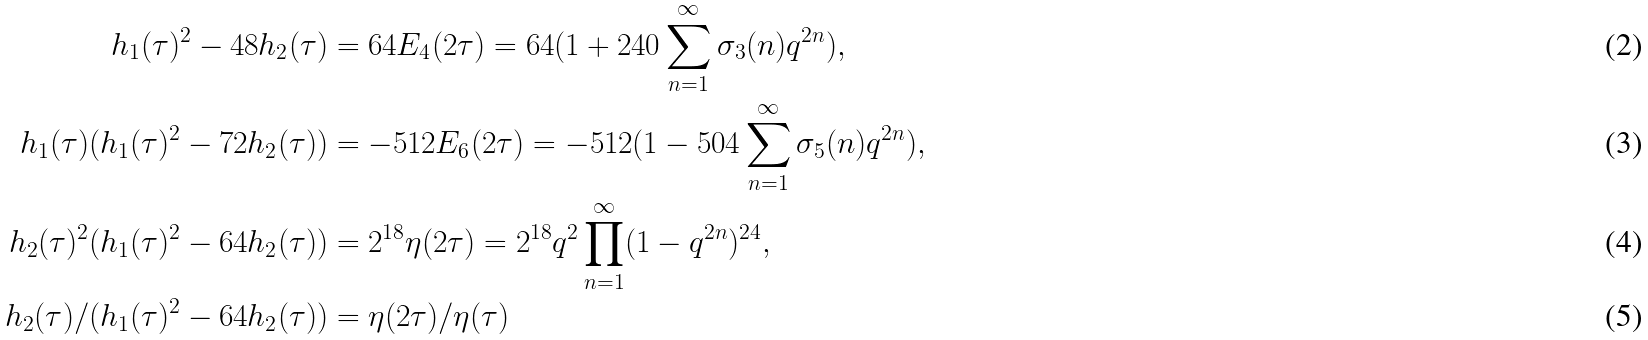<formula> <loc_0><loc_0><loc_500><loc_500>h _ { 1 } ( \tau ) ^ { 2 } - 4 8 h _ { 2 } ( \tau ) & = 6 4 E _ { 4 } ( 2 \tau ) = 6 4 ( 1 + 2 4 0 \sum _ { n = 1 } ^ { \infty } \sigma _ { 3 } ( n ) q ^ { 2 n } ) , \\ h _ { 1 } ( \tau ) ( h _ { 1 } ( \tau ) ^ { 2 } - 7 2 h _ { 2 } ( \tau ) ) & = - 5 1 2 E _ { 6 } ( 2 \tau ) = - 5 1 2 ( 1 - 5 0 4 \sum _ { n = 1 } ^ { \infty } \sigma _ { 5 } ( n ) q ^ { 2 n } ) , \\ h _ { 2 } ( \tau ) ^ { 2 } ( h _ { 1 } ( \tau ) ^ { 2 } - 6 4 h _ { 2 } ( \tau ) ) & = 2 ^ { 1 8 } \eta ( 2 \tau ) = 2 ^ { 1 8 } q ^ { 2 } \prod _ { n = 1 } ^ { \infty } ( 1 - q ^ { 2 n } ) ^ { 2 4 } , \\ h _ { 2 } ( \tau ) / ( h _ { 1 } ( \tau ) ^ { 2 } - 6 4 h _ { 2 } ( \tau ) ) & = \eta ( 2 \tau ) / \eta ( \tau )</formula> 